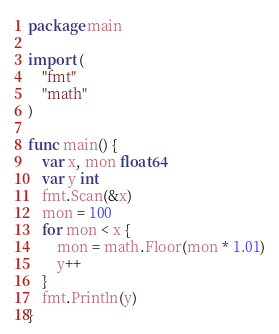Convert code to text. <code><loc_0><loc_0><loc_500><loc_500><_Go_>package main

import (
	"fmt"
	"math"
)

func main() {
	var x, mon float64
	var y int
	fmt.Scan(&x)
	mon = 100
	for mon < x {
		mon = math.Floor(mon * 1.01)
		y++
	}
	fmt.Println(y)
}
</code> 